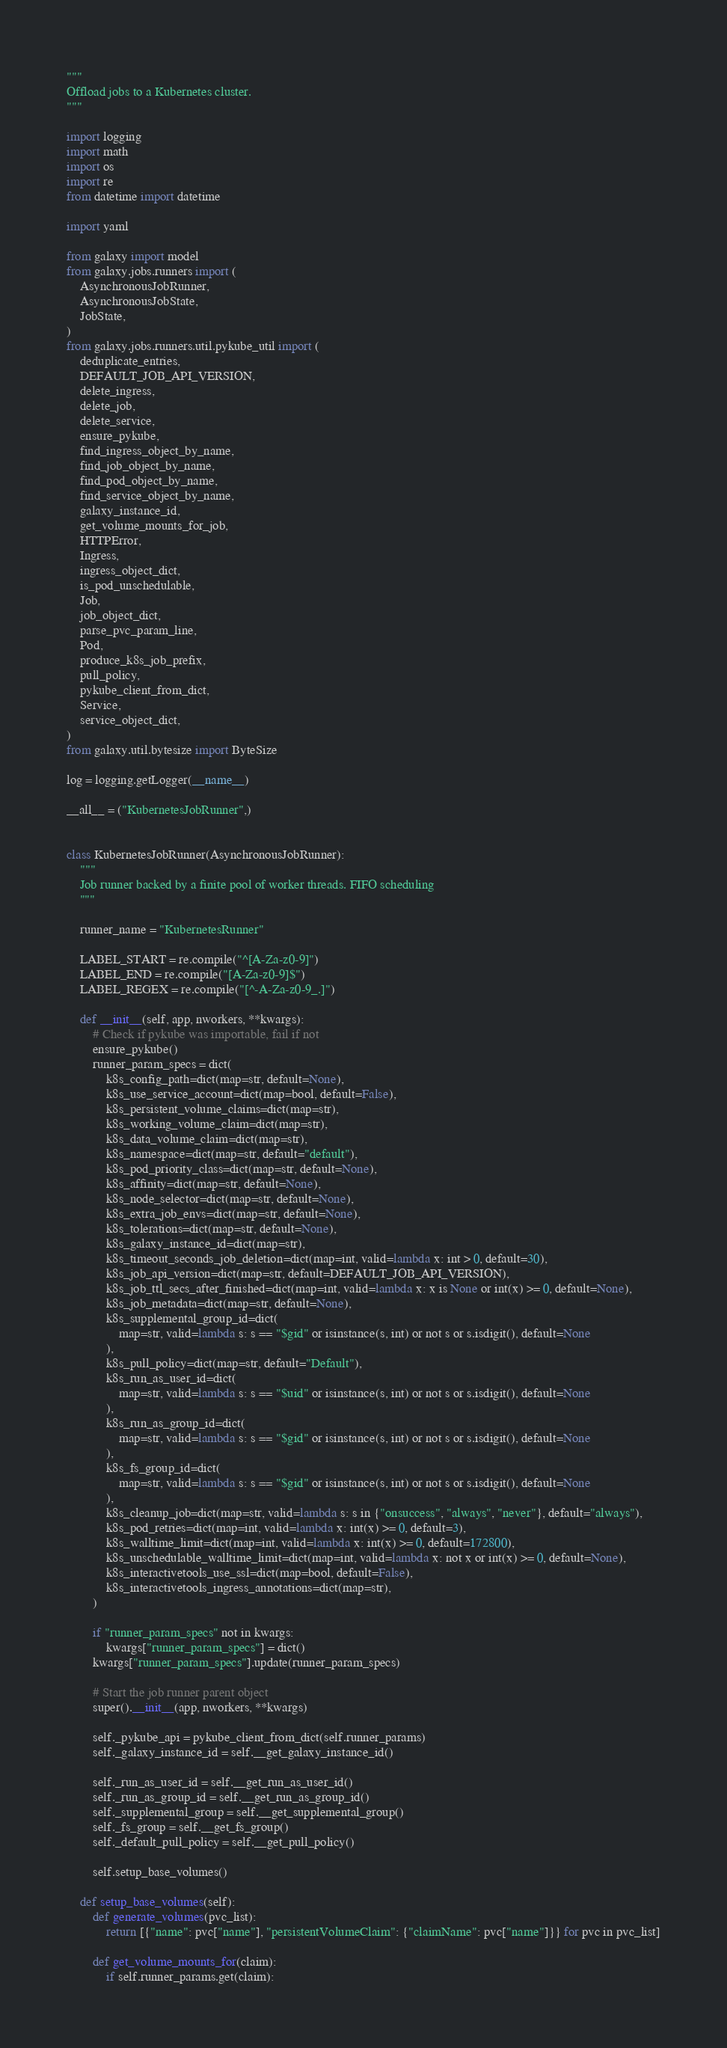<code> <loc_0><loc_0><loc_500><loc_500><_Python_>"""
Offload jobs to a Kubernetes cluster.
"""

import logging
import math
import os
import re
from datetime import datetime

import yaml

from galaxy import model
from galaxy.jobs.runners import (
    AsynchronousJobRunner,
    AsynchronousJobState,
    JobState,
)
from galaxy.jobs.runners.util.pykube_util import (
    deduplicate_entries,
    DEFAULT_JOB_API_VERSION,
    delete_ingress,
    delete_job,
    delete_service,
    ensure_pykube,
    find_ingress_object_by_name,
    find_job_object_by_name,
    find_pod_object_by_name,
    find_service_object_by_name,
    galaxy_instance_id,
    get_volume_mounts_for_job,
    HTTPError,
    Ingress,
    ingress_object_dict,
    is_pod_unschedulable,
    Job,
    job_object_dict,
    parse_pvc_param_line,
    Pod,
    produce_k8s_job_prefix,
    pull_policy,
    pykube_client_from_dict,
    Service,
    service_object_dict,
)
from galaxy.util.bytesize import ByteSize

log = logging.getLogger(__name__)

__all__ = ("KubernetesJobRunner",)


class KubernetesJobRunner(AsynchronousJobRunner):
    """
    Job runner backed by a finite pool of worker threads. FIFO scheduling
    """

    runner_name = "KubernetesRunner"

    LABEL_START = re.compile("^[A-Za-z0-9]")
    LABEL_END = re.compile("[A-Za-z0-9]$")
    LABEL_REGEX = re.compile("[^-A-Za-z0-9_.]")

    def __init__(self, app, nworkers, **kwargs):
        # Check if pykube was importable, fail if not
        ensure_pykube()
        runner_param_specs = dict(
            k8s_config_path=dict(map=str, default=None),
            k8s_use_service_account=dict(map=bool, default=False),
            k8s_persistent_volume_claims=dict(map=str),
            k8s_working_volume_claim=dict(map=str),
            k8s_data_volume_claim=dict(map=str),
            k8s_namespace=dict(map=str, default="default"),
            k8s_pod_priority_class=dict(map=str, default=None),
            k8s_affinity=dict(map=str, default=None),
            k8s_node_selector=dict(map=str, default=None),
            k8s_extra_job_envs=dict(map=str, default=None),
            k8s_tolerations=dict(map=str, default=None),
            k8s_galaxy_instance_id=dict(map=str),
            k8s_timeout_seconds_job_deletion=dict(map=int, valid=lambda x: int > 0, default=30),
            k8s_job_api_version=dict(map=str, default=DEFAULT_JOB_API_VERSION),
            k8s_job_ttl_secs_after_finished=dict(map=int, valid=lambda x: x is None or int(x) >= 0, default=None),
            k8s_job_metadata=dict(map=str, default=None),
            k8s_supplemental_group_id=dict(
                map=str, valid=lambda s: s == "$gid" or isinstance(s, int) or not s or s.isdigit(), default=None
            ),
            k8s_pull_policy=dict(map=str, default="Default"),
            k8s_run_as_user_id=dict(
                map=str, valid=lambda s: s == "$uid" or isinstance(s, int) or not s or s.isdigit(), default=None
            ),
            k8s_run_as_group_id=dict(
                map=str, valid=lambda s: s == "$gid" or isinstance(s, int) or not s or s.isdigit(), default=None
            ),
            k8s_fs_group_id=dict(
                map=str, valid=lambda s: s == "$gid" or isinstance(s, int) or not s or s.isdigit(), default=None
            ),
            k8s_cleanup_job=dict(map=str, valid=lambda s: s in {"onsuccess", "always", "never"}, default="always"),
            k8s_pod_retries=dict(map=int, valid=lambda x: int(x) >= 0, default=3),
            k8s_walltime_limit=dict(map=int, valid=lambda x: int(x) >= 0, default=172800),
            k8s_unschedulable_walltime_limit=dict(map=int, valid=lambda x: not x or int(x) >= 0, default=None),
            k8s_interactivetools_use_ssl=dict(map=bool, default=False),
            k8s_interactivetools_ingress_annotations=dict(map=str),
        )

        if "runner_param_specs" not in kwargs:
            kwargs["runner_param_specs"] = dict()
        kwargs["runner_param_specs"].update(runner_param_specs)

        # Start the job runner parent object
        super().__init__(app, nworkers, **kwargs)

        self._pykube_api = pykube_client_from_dict(self.runner_params)
        self._galaxy_instance_id = self.__get_galaxy_instance_id()

        self._run_as_user_id = self.__get_run_as_user_id()
        self._run_as_group_id = self.__get_run_as_group_id()
        self._supplemental_group = self.__get_supplemental_group()
        self._fs_group = self.__get_fs_group()
        self._default_pull_policy = self.__get_pull_policy()

        self.setup_base_volumes()

    def setup_base_volumes(self):
        def generate_volumes(pvc_list):
            return [{"name": pvc["name"], "persistentVolumeClaim": {"claimName": pvc["name"]}} for pvc in pvc_list]

        def get_volume_mounts_for(claim):
            if self.runner_params.get(claim):</code> 